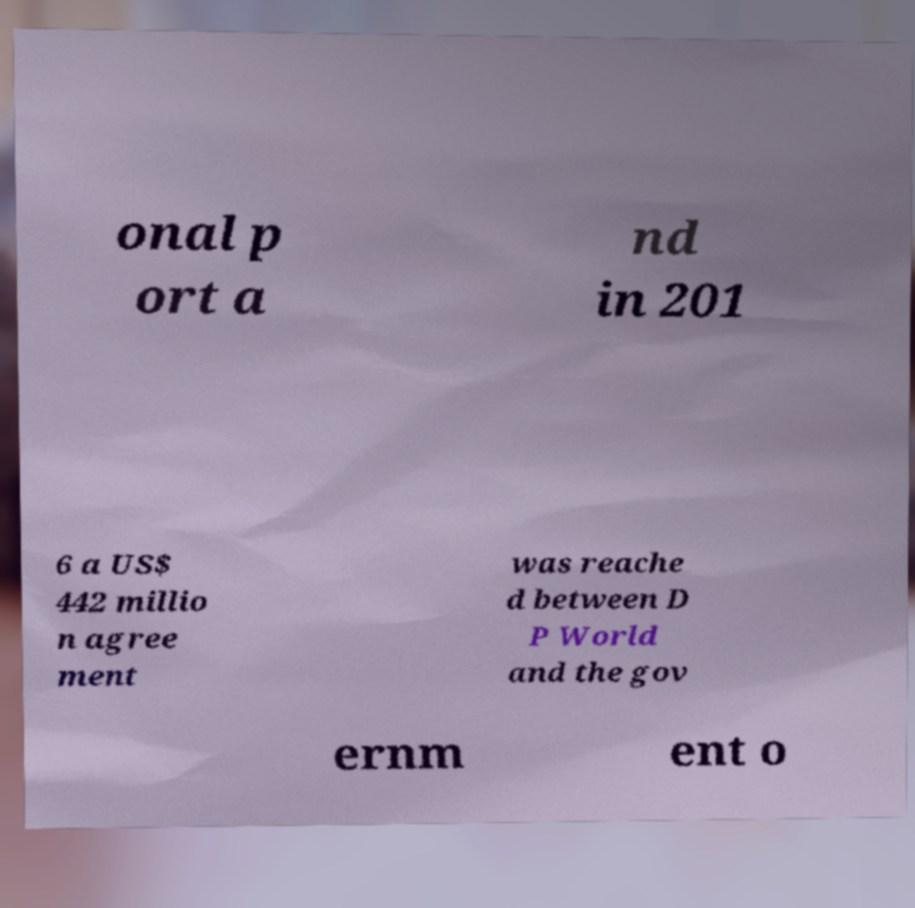Can you read and provide the text displayed in the image?This photo seems to have some interesting text. Can you extract and type it out for me? onal p ort a nd in 201 6 a US$ 442 millio n agree ment was reache d between D P World and the gov ernm ent o 